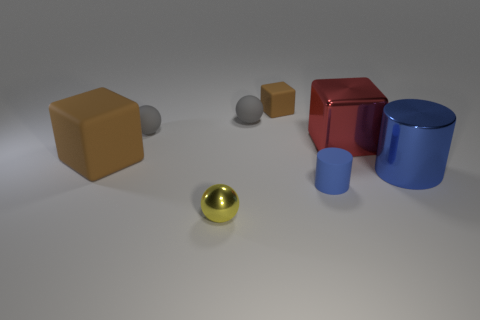What number of other objects are the same material as the tiny brown thing?
Provide a short and direct response. 4. Is the number of metal blocks to the left of the tiny brown thing less than the number of brown rubber objects right of the big brown thing?
Provide a succinct answer. Yes. There is a cylinder on the right side of the small blue rubber cylinder; how big is it?
Offer a terse response. Large. Do the shiny cube and the yellow sphere have the same size?
Provide a succinct answer. No. What number of things are both right of the big brown rubber thing and in front of the red metal thing?
Provide a succinct answer. 3. How many brown things are big metallic blocks or small matte cubes?
Provide a short and direct response. 1. What number of shiny objects are either yellow objects or blue cubes?
Provide a succinct answer. 1. Is there a tiny yellow metal thing?
Your answer should be very brief. Yes. Do the small metal object and the blue rubber thing have the same shape?
Your answer should be compact. No. There is a sphere that is in front of the blue cylinder that is right of the red cube; what number of brown things are to the left of it?
Provide a short and direct response. 1. 